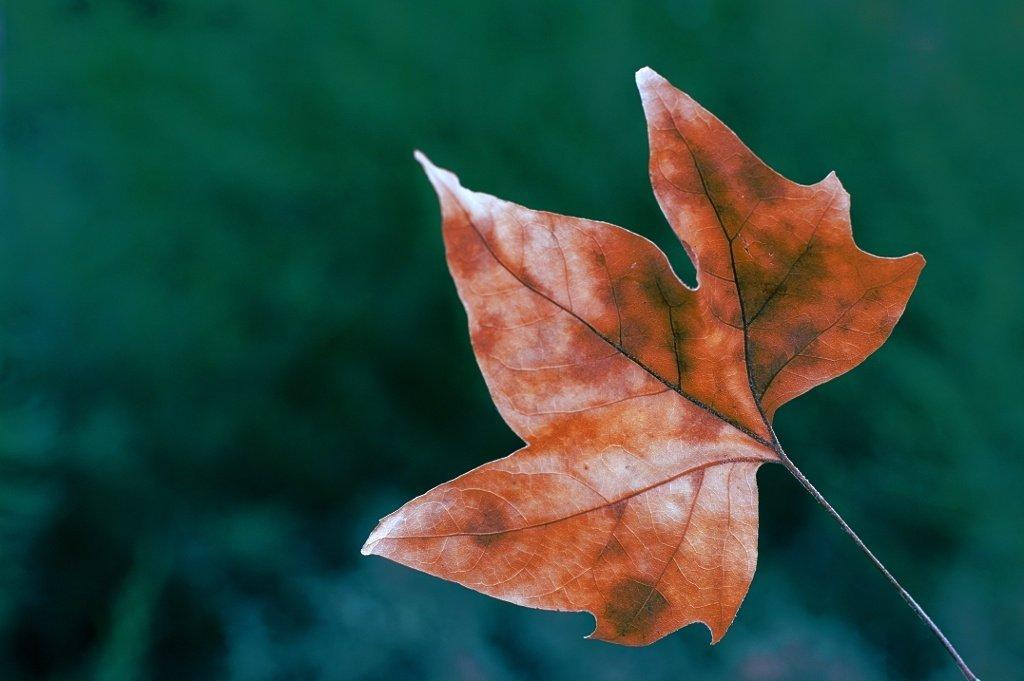What is the main subject of the image? The main subject of the image is a leaf. Can you describe the background of the image? The background of the image is blurred. How many lizards can be seen hiding behind the leaf in the image? There are no lizards present in the image; it only features a leaf. What type of crook might be involved in the creation of the blurred background in the image? The blurred background is a result of the camera's focus and does not involve any crooks or intentional manipulation. 